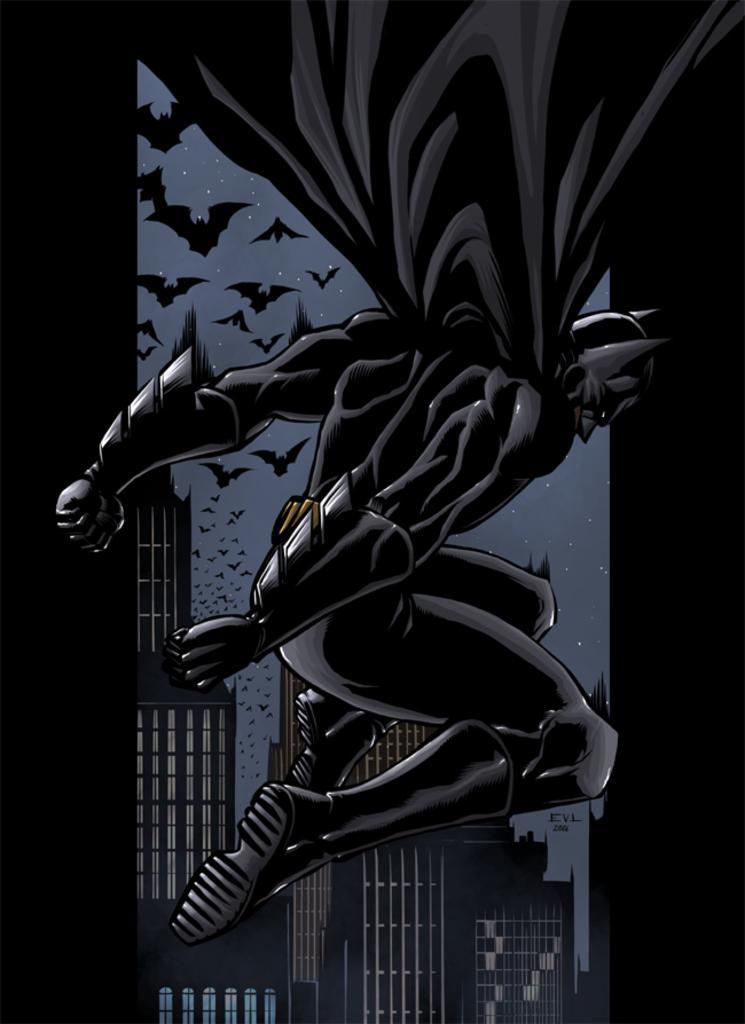Could you give a brief overview of what you see in this image? In the foreground of this animated image, there is batman in the air. In the background, there are few bats in the sky and the buildings. 